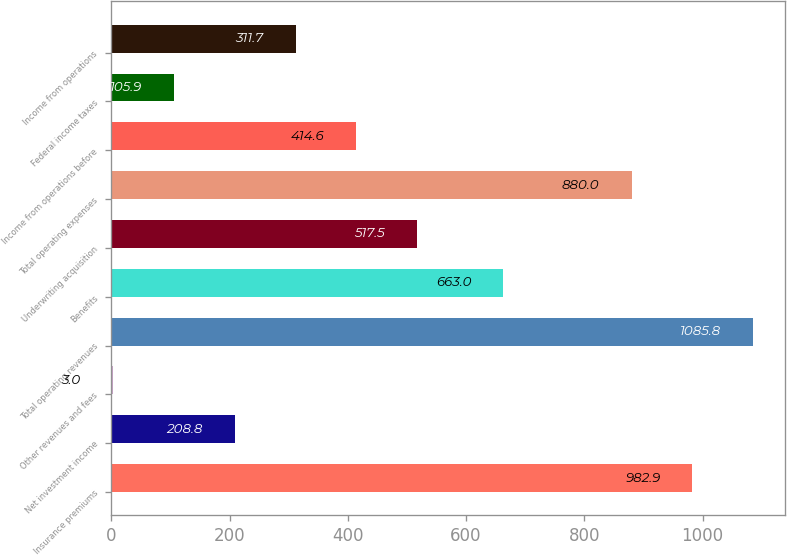<chart> <loc_0><loc_0><loc_500><loc_500><bar_chart><fcel>Insurance premiums<fcel>Net investment income<fcel>Other revenues and fees<fcel>Total operating revenues<fcel>Benefits<fcel>Underwriting acquisition<fcel>Total operating expenses<fcel>Income from operations before<fcel>Federal income taxes<fcel>Income from operations<nl><fcel>982.9<fcel>208.8<fcel>3<fcel>1085.8<fcel>663<fcel>517.5<fcel>880<fcel>414.6<fcel>105.9<fcel>311.7<nl></chart> 